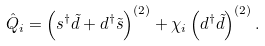<formula> <loc_0><loc_0><loc_500><loc_500>\hat { Q } _ { i } = \left ( s ^ { \dag } \tilde { d } + d ^ { \dag } \tilde { s } \right ) ^ { ( 2 ) } + \chi _ { i } \left ( d ^ { \dag } \tilde { d } \right ) ^ { ( 2 ) } .</formula> 